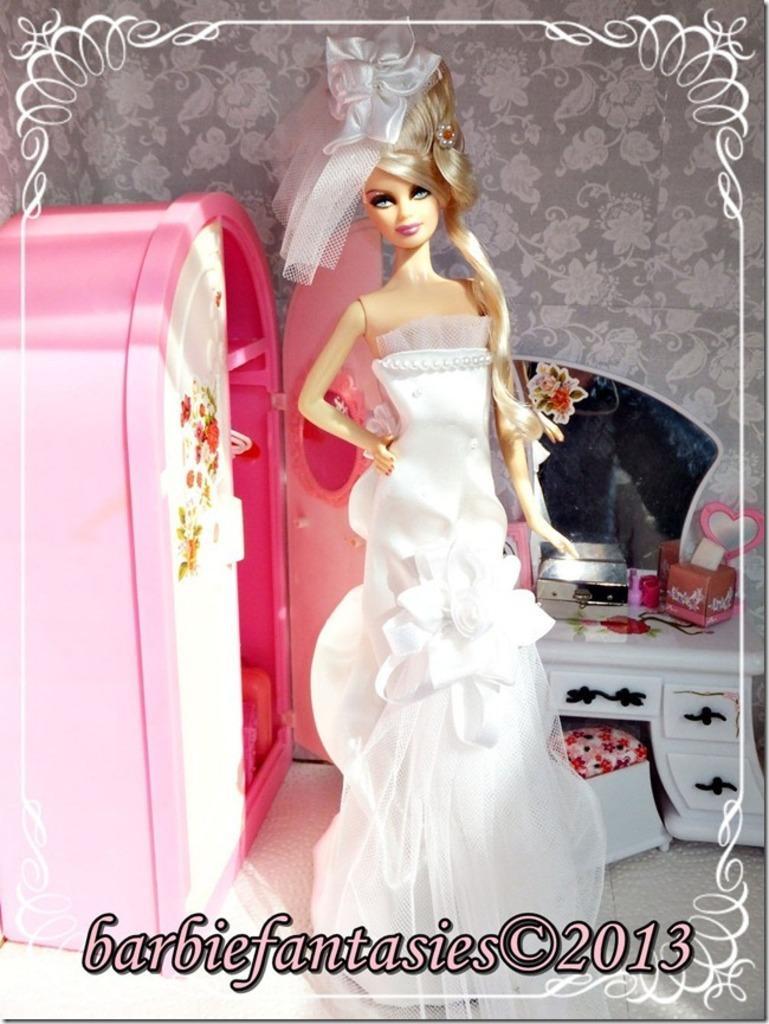Could you give a brief overview of what you see in this image? In this picture, we can see some toys like doll, table with mirror, and some pink color objects, and the wall, and some text on the bottom side of the picture. 